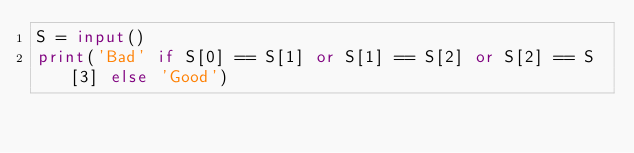Convert code to text. <code><loc_0><loc_0><loc_500><loc_500><_Python_>S = input()
print('Bad' if S[0] == S[1] or S[1] == S[2] or S[2] == S[3] else 'Good')</code> 